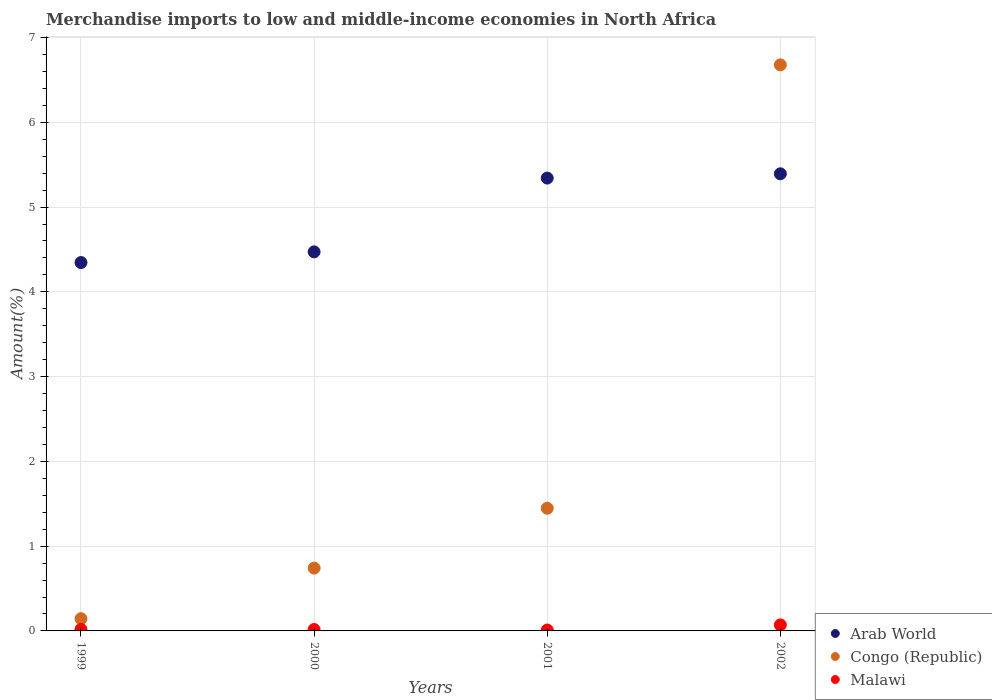Is the number of dotlines equal to the number of legend labels?
Give a very brief answer. Yes. What is the percentage of amount earned from merchandise imports in Malawi in 2002?
Your response must be concise. 0.07. Across all years, what is the maximum percentage of amount earned from merchandise imports in Congo (Republic)?
Offer a terse response. 6.68. Across all years, what is the minimum percentage of amount earned from merchandise imports in Malawi?
Make the answer very short. 0.01. In which year was the percentage of amount earned from merchandise imports in Congo (Republic) maximum?
Your response must be concise. 2002. In which year was the percentage of amount earned from merchandise imports in Arab World minimum?
Give a very brief answer. 1999. What is the total percentage of amount earned from merchandise imports in Congo (Republic) in the graph?
Your response must be concise. 9.01. What is the difference between the percentage of amount earned from merchandise imports in Malawi in 2000 and that in 2001?
Offer a very short reply. 0.01. What is the difference between the percentage of amount earned from merchandise imports in Arab World in 2002 and the percentage of amount earned from merchandise imports in Congo (Republic) in 1999?
Your response must be concise. 5.25. What is the average percentage of amount earned from merchandise imports in Malawi per year?
Keep it short and to the point. 0.03. In the year 1999, what is the difference between the percentage of amount earned from merchandise imports in Malawi and percentage of amount earned from merchandise imports in Arab World?
Make the answer very short. -4.33. In how many years, is the percentage of amount earned from merchandise imports in Malawi greater than 4.8 %?
Your answer should be very brief. 0. What is the ratio of the percentage of amount earned from merchandise imports in Congo (Republic) in 1999 to that in 2002?
Offer a terse response. 0.02. What is the difference between the highest and the second highest percentage of amount earned from merchandise imports in Congo (Republic)?
Provide a succinct answer. 5.23. What is the difference between the highest and the lowest percentage of amount earned from merchandise imports in Congo (Republic)?
Your response must be concise. 6.53. Is the sum of the percentage of amount earned from merchandise imports in Arab World in 2001 and 2002 greater than the maximum percentage of amount earned from merchandise imports in Congo (Republic) across all years?
Your answer should be compact. Yes. Does the percentage of amount earned from merchandise imports in Arab World monotonically increase over the years?
Your answer should be compact. Yes. Is the percentage of amount earned from merchandise imports in Malawi strictly greater than the percentage of amount earned from merchandise imports in Arab World over the years?
Give a very brief answer. No. Is the percentage of amount earned from merchandise imports in Congo (Republic) strictly less than the percentage of amount earned from merchandise imports in Malawi over the years?
Provide a short and direct response. No. How many years are there in the graph?
Ensure brevity in your answer.  4. Where does the legend appear in the graph?
Give a very brief answer. Bottom right. How are the legend labels stacked?
Make the answer very short. Vertical. What is the title of the graph?
Ensure brevity in your answer.  Merchandise imports to low and middle-income economies in North Africa. Does "San Marino" appear as one of the legend labels in the graph?
Your answer should be compact. No. What is the label or title of the X-axis?
Make the answer very short. Years. What is the label or title of the Y-axis?
Ensure brevity in your answer.  Amount(%). What is the Amount(%) in Arab World in 1999?
Offer a very short reply. 4.35. What is the Amount(%) in Congo (Republic) in 1999?
Ensure brevity in your answer.  0.14. What is the Amount(%) of Malawi in 1999?
Provide a short and direct response. 0.02. What is the Amount(%) of Arab World in 2000?
Offer a terse response. 4.47. What is the Amount(%) in Congo (Republic) in 2000?
Your answer should be compact. 0.74. What is the Amount(%) of Malawi in 2000?
Your answer should be very brief. 0.02. What is the Amount(%) in Arab World in 2001?
Offer a terse response. 5.34. What is the Amount(%) of Congo (Republic) in 2001?
Ensure brevity in your answer.  1.45. What is the Amount(%) of Malawi in 2001?
Make the answer very short. 0.01. What is the Amount(%) of Arab World in 2002?
Provide a succinct answer. 5.39. What is the Amount(%) in Congo (Republic) in 2002?
Offer a very short reply. 6.68. What is the Amount(%) of Malawi in 2002?
Provide a short and direct response. 0.07. Across all years, what is the maximum Amount(%) of Arab World?
Your answer should be very brief. 5.39. Across all years, what is the maximum Amount(%) of Congo (Republic)?
Make the answer very short. 6.68. Across all years, what is the maximum Amount(%) in Malawi?
Ensure brevity in your answer.  0.07. Across all years, what is the minimum Amount(%) in Arab World?
Make the answer very short. 4.35. Across all years, what is the minimum Amount(%) in Congo (Republic)?
Your answer should be compact. 0.14. Across all years, what is the minimum Amount(%) of Malawi?
Provide a succinct answer. 0.01. What is the total Amount(%) in Arab World in the graph?
Make the answer very short. 19.55. What is the total Amount(%) in Congo (Republic) in the graph?
Your answer should be very brief. 9.01. What is the total Amount(%) in Malawi in the graph?
Give a very brief answer. 0.12. What is the difference between the Amount(%) of Arab World in 1999 and that in 2000?
Make the answer very short. -0.13. What is the difference between the Amount(%) of Congo (Republic) in 1999 and that in 2000?
Keep it short and to the point. -0.6. What is the difference between the Amount(%) of Arab World in 1999 and that in 2001?
Your answer should be very brief. -1. What is the difference between the Amount(%) of Congo (Republic) in 1999 and that in 2001?
Provide a succinct answer. -1.3. What is the difference between the Amount(%) in Malawi in 1999 and that in 2001?
Keep it short and to the point. 0.01. What is the difference between the Amount(%) in Arab World in 1999 and that in 2002?
Provide a short and direct response. -1.05. What is the difference between the Amount(%) of Congo (Republic) in 1999 and that in 2002?
Make the answer very short. -6.53. What is the difference between the Amount(%) of Malawi in 1999 and that in 2002?
Offer a very short reply. -0.05. What is the difference between the Amount(%) of Arab World in 2000 and that in 2001?
Offer a very short reply. -0.87. What is the difference between the Amount(%) of Congo (Republic) in 2000 and that in 2001?
Give a very brief answer. -0.71. What is the difference between the Amount(%) of Malawi in 2000 and that in 2001?
Your answer should be very brief. 0.01. What is the difference between the Amount(%) in Arab World in 2000 and that in 2002?
Your response must be concise. -0.92. What is the difference between the Amount(%) of Congo (Republic) in 2000 and that in 2002?
Your answer should be compact. -5.94. What is the difference between the Amount(%) in Malawi in 2000 and that in 2002?
Your response must be concise. -0.05. What is the difference between the Amount(%) of Arab World in 2001 and that in 2002?
Ensure brevity in your answer.  -0.05. What is the difference between the Amount(%) in Congo (Republic) in 2001 and that in 2002?
Your answer should be very brief. -5.23. What is the difference between the Amount(%) in Malawi in 2001 and that in 2002?
Offer a very short reply. -0.06. What is the difference between the Amount(%) of Arab World in 1999 and the Amount(%) of Congo (Republic) in 2000?
Ensure brevity in your answer.  3.6. What is the difference between the Amount(%) of Arab World in 1999 and the Amount(%) of Malawi in 2000?
Make the answer very short. 4.33. What is the difference between the Amount(%) in Congo (Republic) in 1999 and the Amount(%) in Malawi in 2000?
Your response must be concise. 0.13. What is the difference between the Amount(%) of Arab World in 1999 and the Amount(%) of Congo (Republic) in 2001?
Keep it short and to the point. 2.9. What is the difference between the Amount(%) in Arab World in 1999 and the Amount(%) in Malawi in 2001?
Offer a very short reply. 4.33. What is the difference between the Amount(%) in Congo (Republic) in 1999 and the Amount(%) in Malawi in 2001?
Give a very brief answer. 0.13. What is the difference between the Amount(%) in Arab World in 1999 and the Amount(%) in Congo (Republic) in 2002?
Make the answer very short. -2.33. What is the difference between the Amount(%) of Arab World in 1999 and the Amount(%) of Malawi in 2002?
Provide a short and direct response. 4.27. What is the difference between the Amount(%) in Congo (Republic) in 1999 and the Amount(%) in Malawi in 2002?
Keep it short and to the point. 0.07. What is the difference between the Amount(%) of Arab World in 2000 and the Amount(%) of Congo (Republic) in 2001?
Provide a short and direct response. 3.02. What is the difference between the Amount(%) of Arab World in 2000 and the Amount(%) of Malawi in 2001?
Your answer should be compact. 4.46. What is the difference between the Amount(%) in Congo (Republic) in 2000 and the Amount(%) in Malawi in 2001?
Give a very brief answer. 0.73. What is the difference between the Amount(%) in Arab World in 2000 and the Amount(%) in Congo (Republic) in 2002?
Keep it short and to the point. -2.21. What is the difference between the Amount(%) of Arab World in 2000 and the Amount(%) of Malawi in 2002?
Your response must be concise. 4.4. What is the difference between the Amount(%) in Congo (Republic) in 2000 and the Amount(%) in Malawi in 2002?
Offer a very short reply. 0.67. What is the difference between the Amount(%) in Arab World in 2001 and the Amount(%) in Congo (Republic) in 2002?
Offer a very short reply. -1.34. What is the difference between the Amount(%) in Arab World in 2001 and the Amount(%) in Malawi in 2002?
Provide a short and direct response. 5.27. What is the difference between the Amount(%) of Congo (Republic) in 2001 and the Amount(%) of Malawi in 2002?
Ensure brevity in your answer.  1.38. What is the average Amount(%) in Arab World per year?
Your response must be concise. 4.89. What is the average Amount(%) of Congo (Republic) per year?
Make the answer very short. 2.25. What is the average Amount(%) in Malawi per year?
Your answer should be very brief. 0.03. In the year 1999, what is the difference between the Amount(%) in Arab World and Amount(%) in Congo (Republic)?
Keep it short and to the point. 4.2. In the year 1999, what is the difference between the Amount(%) of Arab World and Amount(%) of Malawi?
Your response must be concise. 4.33. In the year 1999, what is the difference between the Amount(%) of Congo (Republic) and Amount(%) of Malawi?
Make the answer very short. 0.13. In the year 2000, what is the difference between the Amount(%) of Arab World and Amount(%) of Congo (Republic)?
Make the answer very short. 3.73. In the year 2000, what is the difference between the Amount(%) in Arab World and Amount(%) in Malawi?
Your answer should be very brief. 4.45. In the year 2000, what is the difference between the Amount(%) in Congo (Republic) and Amount(%) in Malawi?
Offer a terse response. 0.72. In the year 2001, what is the difference between the Amount(%) of Arab World and Amount(%) of Congo (Republic)?
Offer a terse response. 3.9. In the year 2001, what is the difference between the Amount(%) of Arab World and Amount(%) of Malawi?
Keep it short and to the point. 5.33. In the year 2001, what is the difference between the Amount(%) in Congo (Republic) and Amount(%) in Malawi?
Your answer should be compact. 1.44. In the year 2002, what is the difference between the Amount(%) of Arab World and Amount(%) of Congo (Republic)?
Provide a succinct answer. -1.29. In the year 2002, what is the difference between the Amount(%) in Arab World and Amount(%) in Malawi?
Offer a terse response. 5.32. In the year 2002, what is the difference between the Amount(%) in Congo (Republic) and Amount(%) in Malawi?
Your answer should be very brief. 6.61. What is the ratio of the Amount(%) in Arab World in 1999 to that in 2000?
Give a very brief answer. 0.97. What is the ratio of the Amount(%) of Congo (Republic) in 1999 to that in 2000?
Make the answer very short. 0.19. What is the ratio of the Amount(%) of Malawi in 1999 to that in 2000?
Provide a succinct answer. 1.02. What is the ratio of the Amount(%) in Arab World in 1999 to that in 2001?
Ensure brevity in your answer.  0.81. What is the ratio of the Amount(%) of Congo (Republic) in 1999 to that in 2001?
Your answer should be very brief. 0.1. What is the ratio of the Amount(%) of Malawi in 1999 to that in 2001?
Keep it short and to the point. 1.6. What is the ratio of the Amount(%) of Arab World in 1999 to that in 2002?
Ensure brevity in your answer.  0.81. What is the ratio of the Amount(%) in Congo (Republic) in 1999 to that in 2002?
Your response must be concise. 0.02. What is the ratio of the Amount(%) in Malawi in 1999 to that in 2002?
Provide a succinct answer. 0.24. What is the ratio of the Amount(%) of Arab World in 2000 to that in 2001?
Make the answer very short. 0.84. What is the ratio of the Amount(%) of Congo (Republic) in 2000 to that in 2001?
Your answer should be compact. 0.51. What is the ratio of the Amount(%) of Malawi in 2000 to that in 2001?
Give a very brief answer. 1.56. What is the ratio of the Amount(%) in Arab World in 2000 to that in 2002?
Give a very brief answer. 0.83. What is the ratio of the Amount(%) in Congo (Republic) in 2000 to that in 2002?
Give a very brief answer. 0.11. What is the ratio of the Amount(%) of Malawi in 2000 to that in 2002?
Keep it short and to the point. 0.24. What is the ratio of the Amount(%) in Arab World in 2001 to that in 2002?
Offer a very short reply. 0.99. What is the ratio of the Amount(%) in Congo (Republic) in 2001 to that in 2002?
Your answer should be compact. 0.22. What is the ratio of the Amount(%) of Malawi in 2001 to that in 2002?
Offer a very short reply. 0.15. What is the difference between the highest and the second highest Amount(%) in Arab World?
Your response must be concise. 0.05. What is the difference between the highest and the second highest Amount(%) of Congo (Republic)?
Provide a short and direct response. 5.23. What is the difference between the highest and the second highest Amount(%) of Malawi?
Keep it short and to the point. 0.05. What is the difference between the highest and the lowest Amount(%) of Arab World?
Provide a succinct answer. 1.05. What is the difference between the highest and the lowest Amount(%) in Congo (Republic)?
Offer a terse response. 6.53. What is the difference between the highest and the lowest Amount(%) in Malawi?
Offer a terse response. 0.06. 